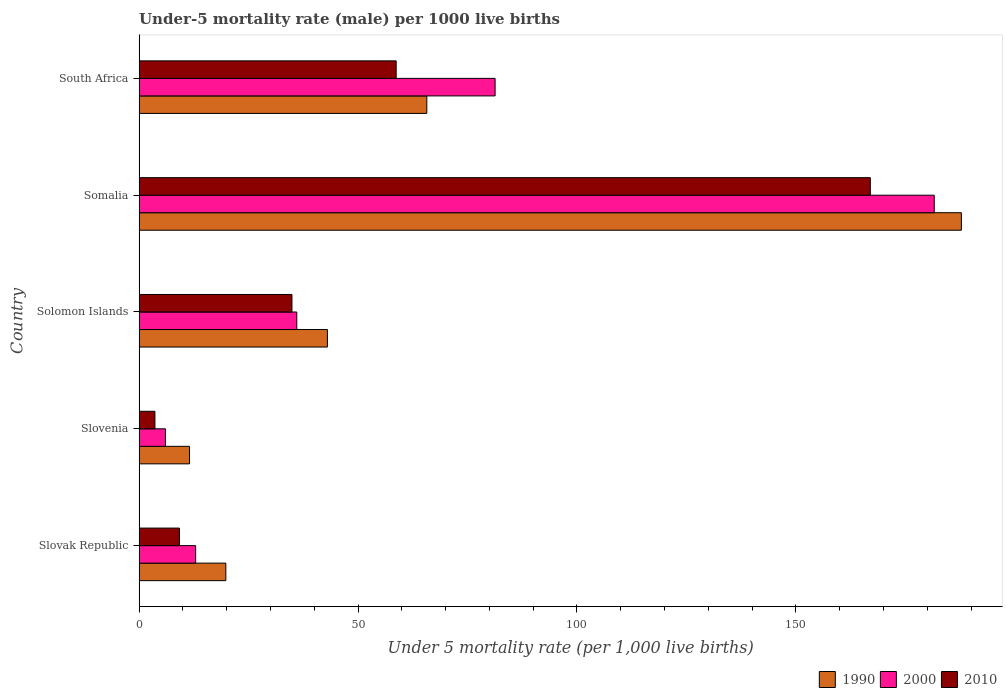Are the number of bars per tick equal to the number of legend labels?
Offer a very short reply. Yes. How many bars are there on the 3rd tick from the top?
Offer a very short reply. 3. What is the label of the 4th group of bars from the top?
Provide a succinct answer. Slovenia. In how many cases, is the number of bars for a given country not equal to the number of legend labels?
Offer a very short reply. 0. What is the under-five mortality rate in 2000 in South Africa?
Your answer should be compact. 81.3. Across all countries, what is the maximum under-five mortality rate in 1990?
Offer a terse response. 187.8. In which country was the under-five mortality rate in 2000 maximum?
Offer a very short reply. Somalia. In which country was the under-five mortality rate in 2010 minimum?
Offer a terse response. Slovenia. What is the total under-five mortality rate in 1990 in the graph?
Make the answer very short. 327.8. What is the difference between the under-five mortality rate in 2000 in Slovenia and that in South Africa?
Keep it short and to the point. -75.3. What is the difference between the under-five mortality rate in 2000 in South Africa and the under-five mortality rate in 1990 in Somalia?
Keep it short and to the point. -106.5. What is the average under-five mortality rate in 2000 per country?
Your answer should be very brief. 63.56. What is the difference between the under-five mortality rate in 1990 and under-five mortality rate in 2010 in Slovak Republic?
Your answer should be very brief. 10.6. What is the ratio of the under-five mortality rate in 1990 in Solomon Islands to that in South Africa?
Make the answer very short. 0.65. Is the under-five mortality rate in 2010 in Slovenia less than that in Somalia?
Keep it short and to the point. Yes. What is the difference between the highest and the second highest under-five mortality rate in 1990?
Offer a very short reply. 122.1. What is the difference between the highest and the lowest under-five mortality rate in 1990?
Your response must be concise. 176.3. What does the 1st bar from the top in Slovenia represents?
Give a very brief answer. 2010. What does the 1st bar from the bottom in South Africa represents?
Offer a terse response. 1990. Is it the case that in every country, the sum of the under-five mortality rate in 2000 and under-five mortality rate in 2010 is greater than the under-five mortality rate in 1990?
Provide a succinct answer. No. Are all the bars in the graph horizontal?
Keep it short and to the point. Yes. How many countries are there in the graph?
Offer a terse response. 5. What is the difference between two consecutive major ticks on the X-axis?
Your response must be concise. 50. Does the graph contain grids?
Ensure brevity in your answer.  No. How many legend labels are there?
Make the answer very short. 3. What is the title of the graph?
Keep it short and to the point. Under-5 mortality rate (male) per 1000 live births. What is the label or title of the X-axis?
Make the answer very short. Under 5 mortality rate (per 1,0 live births). What is the label or title of the Y-axis?
Your response must be concise. Country. What is the Under 5 mortality rate (per 1,000 live births) in 1990 in Slovak Republic?
Provide a succinct answer. 19.8. What is the Under 5 mortality rate (per 1,000 live births) of 1990 in Slovenia?
Make the answer very short. 11.5. What is the Under 5 mortality rate (per 1,000 live births) of 2000 in Slovenia?
Provide a succinct answer. 6. What is the Under 5 mortality rate (per 1,000 live births) in 2010 in Solomon Islands?
Your answer should be compact. 34.9. What is the Under 5 mortality rate (per 1,000 live births) of 1990 in Somalia?
Offer a very short reply. 187.8. What is the Under 5 mortality rate (per 1,000 live births) in 2000 in Somalia?
Give a very brief answer. 181.6. What is the Under 5 mortality rate (per 1,000 live births) in 2010 in Somalia?
Your response must be concise. 167. What is the Under 5 mortality rate (per 1,000 live births) in 1990 in South Africa?
Provide a succinct answer. 65.7. What is the Under 5 mortality rate (per 1,000 live births) of 2000 in South Africa?
Your answer should be very brief. 81.3. What is the Under 5 mortality rate (per 1,000 live births) of 2010 in South Africa?
Provide a short and direct response. 58.7. Across all countries, what is the maximum Under 5 mortality rate (per 1,000 live births) of 1990?
Make the answer very short. 187.8. Across all countries, what is the maximum Under 5 mortality rate (per 1,000 live births) in 2000?
Make the answer very short. 181.6. Across all countries, what is the maximum Under 5 mortality rate (per 1,000 live births) in 2010?
Provide a short and direct response. 167. What is the total Under 5 mortality rate (per 1,000 live births) in 1990 in the graph?
Offer a very short reply. 327.8. What is the total Under 5 mortality rate (per 1,000 live births) of 2000 in the graph?
Your response must be concise. 317.8. What is the total Under 5 mortality rate (per 1,000 live births) of 2010 in the graph?
Offer a very short reply. 273.4. What is the difference between the Under 5 mortality rate (per 1,000 live births) in 2000 in Slovak Republic and that in Slovenia?
Keep it short and to the point. 6.9. What is the difference between the Under 5 mortality rate (per 1,000 live births) in 1990 in Slovak Republic and that in Solomon Islands?
Your answer should be very brief. -23.2. What is the difference between the Under 5 mortality rate (per 1,000 live births) of 2000 in Slovak Republic and that in Solomon Islands?
Give a very brief answer. -23.1. What is the difference between the Under 5 mortality rate (per 1,000 live births) in 2010 in Slovak Republic and that in Solomon Islands?
Give a very brief answer. -25.7. What is the difference between the Under 5 mortality rate (per 1,000 live births) of 1990 in Slovak Republic and that in Somalia?
Offer a terse response. -168. What is the difference between the Under 5 mortality rate (per 1,000 live births) of 2000 in Slovak Republic and that in Somalia?
Ensure brevity in your answer.  -168.7. What is the difference between the Under 5 mortality rate (per 1,000 live births) in 2010 in Slovak Republic and that in Somalia?
Give a very brief answer. -157.8. What is the difference between the Under 5 mortality rate (per 1,000 live births) in 1990 in Slovak Republic and that in South Africa?
Offer a very short reply. -45.9. What is the difference between the Under 5 mortality rate (per 1,000 live births) in 2000 in Slovak Republic and that in South Africa?
Ensure brevity in your answer.  -68.4. What is the difference between the Under 5 mortality rate (per 1,000 live births) of 2010 in Slovak Republic and that in South Africa?
Make the answer very short. -49.5. What is the difference between the Under 5 mortality rate (per 1,000 live births) of 1990 in Slovenia and that in Solomon Islands?
Provide a short and direct response. -31.5. What is the difference between the Under 5 mortality rate (per 1,000 live births) in 2010 in Slovenia and that in Solomon Islands?
Make the answer very short. -31.3. What is the difference between the Under 5 mortality rate (per 1,000 live births) of 1990 in Slovenia and that in Somalia?
Make the answer very short. -176.3. What is the difference between the Under 5 mortality rate (per 1,000 live births) of 2000 in Slovenia and that in Somalia?
Your answer should be very brief. -175.6. What is the difference between the Under 5 mortality rate (per 1,000 live births) of 2010 in Slovenia and that in Somalia?
Make the answer very short. -163.4. What is the difference between the Under 5 mortality rate (per 1,000 live births) of 1990 in Slovenia and that in South Africa?
Give a very brief answer. -54.2. What is the difference between the Under 5 mortality rate (per 1,000 live births) in 2000 in Slovenia and that in South Africa?
Make the answer very short. -75.3. What is the difference between the Under 5 mortality rate (per 1,000 live births) of 2010 in Slovenia and that in South Africa?
Keep it short and to the point. -55.1. What is the difference between the Under 5 mortality rate (per 1,000 live births) in 1990 in Solomon Islands and that in Somalia?
Give a very brief answer. -144.8. What is the difference between the Under 5 mortality rate (per 1,000 live births) in 2000 in Solomon Islands and that in Somalia?
Give a very brief answer. -145.6. What is the difference between the Under 5 mortality rate (per 1,000 live births) in 2010 in Solomon Islands and that in Somalia?
Your answer should be very brief. -132.1. What is the difference between the Under 5 mortality rate (per 1,000 live births) of 1990 in Solomon Islands and that in South Africa?
Offer a very short reply. -22.7. What is the difference between the Under 5 mortality rate (per 1,000 live births) in 2000 in Solomon Islands and that in South Africa?
Make the answer very short. -45.3. What is the difference between the Under 5 mortality rate (per 1,000 live births) of 2010 in Solomon Islands and that in South Africa?
Provide a succinct answer. -23.8. What is the difference between the Under 5 mortality rate (per 1,000 live births) of 1990 in Somalia and that in South Africa?
Ensure brevity in your answer.  122.1. What is the difference between the Under 5 mortality rate (per 1,000 live births) of 2000 in Somalia and that in South Africa?
Provide a short and direct response. 100.3. What is the difference between the Under 5 mortality rate (per 1,000 live births) in 2010 in Somalia and that in South Africa?
Offer a very short reply. 108.3. What is the difference between the Under 5 mortality rate (per 1,000 live births) in 1990 in Slovak Republic and the Under 5 mortality rate (per 1,000 live births) in 2000 in Solomon Islands?
Provide a short and direct response. -16.2. What is the difference between the Under 5 mortality rate (per 1,000 live births) in 1990 in Slovak Republic and the Under 5 mortality rate (per 1,000 live births) in 2010 in Solomon Islands?
Provide a short and direct response. -15.1. What is the difference between the Under 5 mortality rate (per 1,000 live births) in 2000 in Slovak Republic and the Under 5 mortality rate (per 1,000 live births) in 2010 in Solomon Islands?
Provide a succinct answer. -22. What is the difference between the Under 5 mortality rate (per 1,000 live births) in 1990 in Slovak Republic and the Under 5 mortality rate (per 1,000 live births) in 2000 in Somalia?
Your answer should be compact. -161.8. What is the difference between the Under 5 mortality rate (per 1,000 live births) of 1990 in Slovak Republic and the Under 5 mortality rate (per 1,000 live births) of 2010 in Somalia?
Give a very brief answer. -147.2. What is the difference between the Under 5 mortality rate (per 1,000 live births) of 2000 in Slovak Republic and the Under 5 mortality rate (per 1,000 live births) of 2010 in Somalia?
Offer a very short reply. -154.1. What is the difference between the Under 5 mortality rate (per 1,000 live births) in 1990 in Slovak Republic and the Under 5 mortality rate (per 1,000 live births) in 2000 in South Africa?
Your answer should be very brief. -61.5. What is the difference between the Under 5 mortality rate (per 1,000 live births) in 1990 in Slovak Republic and the Under 5 mortality rate (per 1,000 live births) in 2010 in South Africa?
Offer a very short reply. -38.9. What is the difference between the Under 5 mortality rate (per 1,000 live births) in 2000 in Slovak Republic and the Under 5 mortality rate (per 1,000 live births) in 2010 in South Africa?
Offer a very short reply. -45.8. What is the difference between the Under 5 mortality rate (per 1,000 live births) in 1990 in Slovenia and the Under 5 mortality rate (per 1,000 live births) in 2000 in Solomon Islands?
Keep it short and to the point. -24.5. What is the difference between the Under 5 mortality rate (per 1,000 live births) in 1990 in Slovenia and the Under 5 mortality rate (per 1,000 live births) in 2010 in Solomon Islands?
Your answer should be compact. -23.4. What is the difference between the Under 5 mortality rate (per 1,000 live births) in 2000 in Slovenia and the Under 5 mortality rate (per 1,000 live births) in 2010 in Solomon Islands?
Offer a terse response. -28.9. What is the difference between the Under 5 mortality rate (per 1,000 live births) of 1990 in Slovenia and the Under 5 mortality rate (per 1,000 live births) of 2000 in Somalia?
Your answer should be compact. -170.1. What is the difference between the Under 5 mortality rate (per 1,000 live births) of 1990 in Slovenia and the Under 5 mortality rate (per 1,000 live births) of 2010 in Somalia?
Your answer should be very brief. -155.5. What is the difference between the Under 5 mortality rate (per 1,000 live births) in 2000 in Slovenia and the Under 5 mortality rate (per 1,000 live births) in 2010 in Somalia?
Ensure brevity in your answer.  -161. What is the difference between the Under 5 mortality rate (per 1,000 live births) of 1990 in Slovenia and the Under 5 mortality rate (per 1,000 live births) of 2000 in South Africa?
Make the answer very short. -69.8. What is the difference between the Under 5 mortality rate (per 1,000 live births) of 1990 in Slovenia and the Under 5 mortality rate (per 1,000 live births) of 2010 in South Africa?
Your response must be concise. -47.2. What is the difference between the Under 5 mortality rate (per 1,000 live births) in 2000 in Slovenia and the Under 5 mortality rate (per 1,000 live births) in 2010 in South Africa?
Provide a succinct answer. -52.7. What is the difference between the Under 5 mortality rate (per 1,000 live births) in 1990 in Solomon Islands and the Under 5 mortality rate (per 1,000 live births) in 2000 in Somalia?
Your answer should be compact. -138.6. What is the difference between the Under 5 mortality rate (per 1,000 live births) in 1990 in Solomon Islands and the Under 5 mortality rate (per 1,000 live births) in 2010 in Somalia?
Your response must be concise. -124. What is the difference between the Under 5 mortality rate (per 1,000 live births) in 2000 in Solomon Islands and the Under 5 mortality rate (per 1,000 live births) in 2010 in Somalia?
Your answer should be very brief. -131. What is the difference between the Under 5 mortality rate (per 1,000 live births) in 1990 in Solomon Islands and the Under 5 mortality rate (per 1,000 live births) in 2000 in South Africa?
Provide a short and direct response. -38.3. What is the difference between the Under 5 mortality rate (per 1,000 live births) of 1990 in Solomon Islands and the Under 5 mortality rate (per 1,000 live births) of 2010 in South Africa?
Your response must be concise. -15.7. What is the difference between the Under 5 mortality rate (per 1,000 live births) of 2000 in Solomon Islands and the Under 5 mortality rate (per 1,000 live births) of 2010 in South Africa?
Provide a succinct answer. -22.7. What is the difference between the Under 5 mortality rate (per 1,000 live births) of 1990 in Somalia and the Under 5 mortality rate (per 1,000 live births) of 2000 in South Africa?
Your answer should be very brief. 106.5. What is the difference between the Under 5 mortality rate (per 1,000 live births) of 1990 in Somalia and the Under 5 mortality rate (per 1,000 live births) of 2010 in South Africa?
Provide a short and direct response. 129.1. What is the difference between the Under 5 mortality rate (per 1,000 live births) of 2000 in Somalia and the Under 5 mortality rate (per 1,000 live births) of 2010 in South Africa?
Your answer should be very brief. 122.9. What is the average Under 5 mortality rate (per 1,000 live births) in 1990 per country?
Provide a short and direct response. 65.56. What is the average Under 5 mortality rate (per 1,000 live births) of 2000 per country?
Provide a short and direct response. 63.56. What is the average Under 5 mortality rate (per 1,000 live births) of 2010 per country?
Ensure brevity in your answer.  54.68. What is the difference between the Under 5 mortality rate (per 1,000 live births) of 1990 and Under 5 mortality rate (per 1,000 live births) of 2010 in Slovenia?
Your answer should be compact. 7.9. What is the difference between the Under 5 mortality rate (per 1,000 live births) of 2000 and Under 5 mortality rate (per 1,000 live births) of 2010 in Solomon Islands?
Provide a succinct answer. 1.1. What is the difference between the Under 5 mortality rate (per 1,000 live births) in 1990 and Under 5 mortality rate (per 1,000 live births) in 2000 in Somalia?
Ensure brevity in your answer.  6.2. What is the difference between the Under 5 mortality rate (per 1,000 live births) of 1990 and Under 5 mortality rate (per 1,000 live births) of 2010 in Somalia?
Ensure brevity in your answer.  20.8. What is the difference between the Under 5 mortality rate (per 1,000 live births) in 2000 and Under 5 mortality rate (per 1,000 live births) in 2010 in Somalia?
Your response must be concise. 14.6. What is the difference between the Under 5 mortality rate (per 1,000 live births) in 1990 and Under 5 mortality rate (per 1,000 live births) in 2000 in South Africa?
Ensure brevity in your answer.  -15.6. What is the difference between the Under 5 mortality rate (per 1,000 live births) in 2000 and Under 5 mortality rate (per 1,000 live births) in 2010 in South Africa?
Ensure brevity in your answer.  22.6. What is the ratio of the Under 5 mortality rate (per 1,000 live births) of 1990 in Slovak Republic to that in Slovenia?
Your answer should be compact. 1.72. What is the ratio of the Under 5 mortality rate (per 1,000 live births) in 2000 in Slovak Republic to that in Slovenia?
Offer a very short reply. 2.15. What is the ratio of the Under 5 mortality rate (per 1,000 live births) of 2010 in Slovak Republic to that in Slovenia?
Offer a very short reply. 2.56. What is the ratio of the Under 5 mortality rate (per 1,000 live births) of 1990 in Slovak Republic to that in Solomon Islands?
Ensure brevity in your answer.  0.46. What is the ratio of the Under 5 mortality rate (per 1,000 live births) of 2000 in Slovak Republic to that in Solomon Islands?
Provide a succinct answer. 0.36. What is the ratio of the Under 5 mortality rate (per 1,000 live births) in 2010 in Slovak Republic to that in Solomon Islands?
Your answer should be very brief. 0.26. What is the ratio of the Under 5 mortality rate (per 1,000 live births) of 1990 in Slovak Republic to that in Somalia?
Your answer should be very brief. 0.11. What is the ratio of the Under 5 mortality rate (per 1,000 live births) of 2000 in Slovak Republic to that in Somalia?
Give a very brief answer. 0.07. What is the ratio of the Under 5 mortality rate (per 1,000 live births) of 2010 in Slovak Republic to that in Somalia?
Ensure brevity in your answer.  0.06. What is the ratio of the Under 5 mortality rate (per 1,000 live births) of 1990 in Slovak Republic to that in South Africa?
Offer a very short reply. 0.3. What is the ratio of the Under 5 mortality rate (per 1,000 live births) of 2000 in Slovak Republic to that in South Africa?
Your response must be concise. 0.16. What is the ratio of the Under 5 mortality rate (per 1,000 live births) in 2010 in Slovak Republic to that in South Africa?
Give a very brief answer. 0.16. What is the ratio of the Under 5 mortality rate (per 1,000 live births) in 1990 in Slovenia to that in Solomon Islands?
Offer a terse response. 0.27. What is the ratio of the Under 5 mortality rate (per 1,000 live births) of 2000 in Slovenia to that in Solomon Islands?
Your response must be concise. 0.17. What is the ratio of the Under 5 mortality rate (per 1,000 live births) of 2010 in Slovenia to that in Solomon Islands?
Your answer should be very brief. 0.1. What is the ratio of the Under 5 mortality rate (per 1,000 live births) of 1990 in Slovenia to that in Somalia?
Your answer should be compact. 0.06. What is the ratio of the Under 5 mortality rate (per 1,000 live births) of 2000 in Slovenia to that in Somalia?
Offer a very short reply. 0.03. What is the ratio of the Under 5 mortality rate (per 1,000 live births) in 2010 in Slovenia to that in Somalia?
Offer a very short reply. 0.02. What is the ratio of the Under 5 mortality rate (per 1,000 live births) in 1990 in Slovenia to that in South Africa?
Keep it short and to the point. 0.17. What is the ratio of the Under 5 mortality rate (per 1,000 live births) of 2000 in Slovenia to that in South Africa?
Give a very brief answer. 0.07. What is the ratio of the Under 5 mortality rate (per 1,000 live births) in 2010 in Slovenia to that in South Africa?
Keep it short and to the point. 0.06. What is the ratio of the Under 5 mortality rate (per 1,000 live births) in 1990 in Solomon Islands to that in Somalia?
Your answer should be very brief. 0.23. What is the ratio of the Under 5 mortality rate (per 1,000 live births) in 2000 in Solomon Islands to that in Somalia?
Your answer should be very brief. 0.2. What is the ratio of the Under 5 mortality rate (per 1,000 live births) in 2010 in Solomon Islands to that in Somalia?
Give a very brief answer. 0.21. What is the ratio of the Under 5 mortality rate (per 1,000 live births) of 1990 in Solomon Islands to that in South Africa?
Make the answer very short. 0.65. What is the ratio of the Under 5 mortality rate (per 1,000 live births) of 2000 in Solomon Islands to that in South Africa?
Your answer should be compact. 0.44. What is the ratio of the Under 5 mortality rate (per 1,000 live births) of 2010 in Solomon Islands to that in South Africa?
Ensure brevity in your answer.  0.59. What is the ratio of the Under 5 mortality rate (per 1,000 live births) in 1990 in Somalia to that in South Africa?
Your response must be concise. 2.86. What is the ratio of the Under 5 mortality rate (per 1,000 live births) of 2000 in Somalia to that in South Africa?
Provide a succinct answer. 2.23. What is the ratio of the Under 5 mortality rate (per 1,000 live births) of 2010 in Somalia to that in South Africa?
Ensure brevity in your answer.  2.85. What is the difference between the highest and the second highest Under 5 mortality rate (per 1,000 live births) of 1990?
Keep it short and to the point. 122.1. What is the difference between the highest and the second highest Under 5 mortality rate (per 1,000 live births) of 2000?
Your response must be concise. 100.3. What is the difference between the highest and the second highest Under 5 mortality rate (per 1,000 live births) of 2010?
Your answer should be very brief. 108.3. What is the difference between the highest and the lowest Under 5 mortality rate (per 1,000 live births) in 1990?
Offer a terse response. 176.3. What is the difference between the highest and the lowest Under 5 mortality rate (per 1,000 live births) in 2000?
Offer a very short reply. 175.6. What is the difference between the highest and the lowest Under 5 mortality rate (per 1,000 live births) of 2010?
Your answer should be very brief. 163.4. 